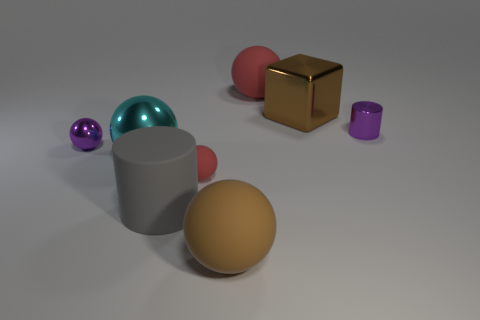Add 1 yellow cylinders. How many objects exist? 9 Subtract all small red spheres. How many spheres are left? 4 Subtract 5 spheres. How many spheres are left? 0 Subtract all big purple metallic things. Subtract all tiny metal cylinders. How many objects are left? 7 Add 8 large rubber balls. How many large rubber balls are left? 10 Add 4 large matte things. How many large matte things exist? 7 Subtract all brown balls. How many balls are left? 4 Subtract 0 gray spheres. How many objects are left? 8 Subtract all balls. How many objects are left? 3 Subtract all gray cylinders. Subtract all brown blocks. How many cylinders are left? 1 